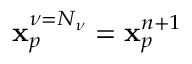Convert formula to latex. <formula><loc_0><loc_0><loc_500><loc_500>x _ { p } ^ { \nu = N _ { \nu } } = x _ { p } ^ { n + 1 }</formula> 